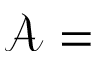<formula> <loc_0><loc_0><loc_500><loc_500>\mathcal { A } =</formula> 